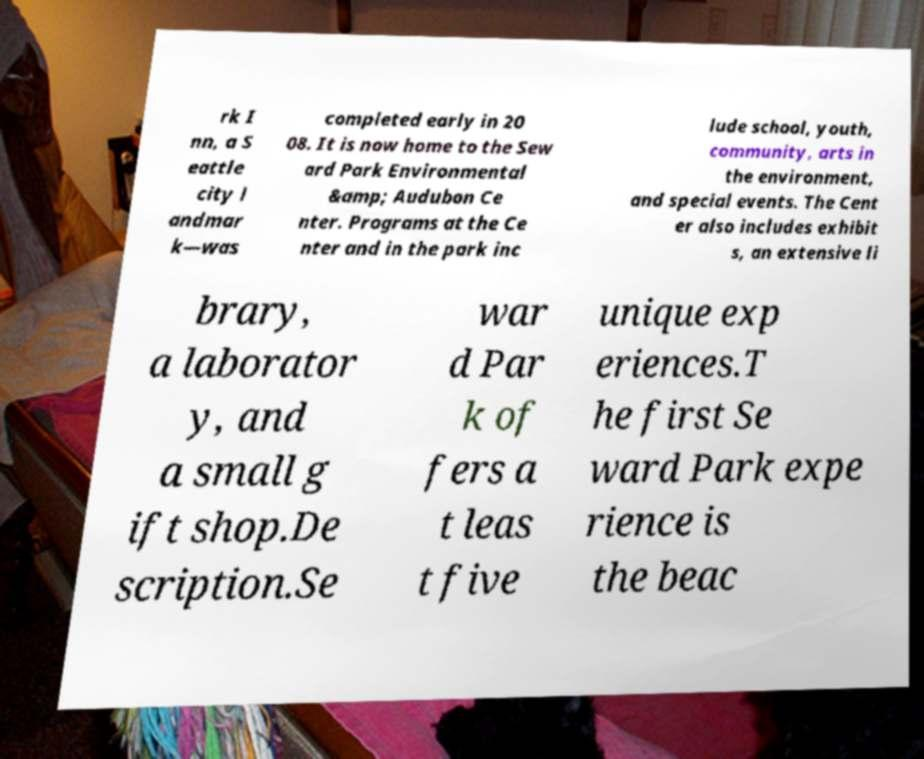Can you accurately transcribe the text from the provided image for me? rk I nn, a S eattle city l andmar k—was completed early in 20 08. It is now home to the Sew ard Park Environmental &amp; Audubon Ce nter. Programs at the Ce nter and in the park inc lude school, youth, community, arts in the environment, and special events. The Cent er also includes exhibit s, an extensive li brary, a laborator y, and a small g ift shop.De scription.Se war d Par k of fers a t leas t five unique exp eriences.T he first Se ward Park expe rience is the beac 